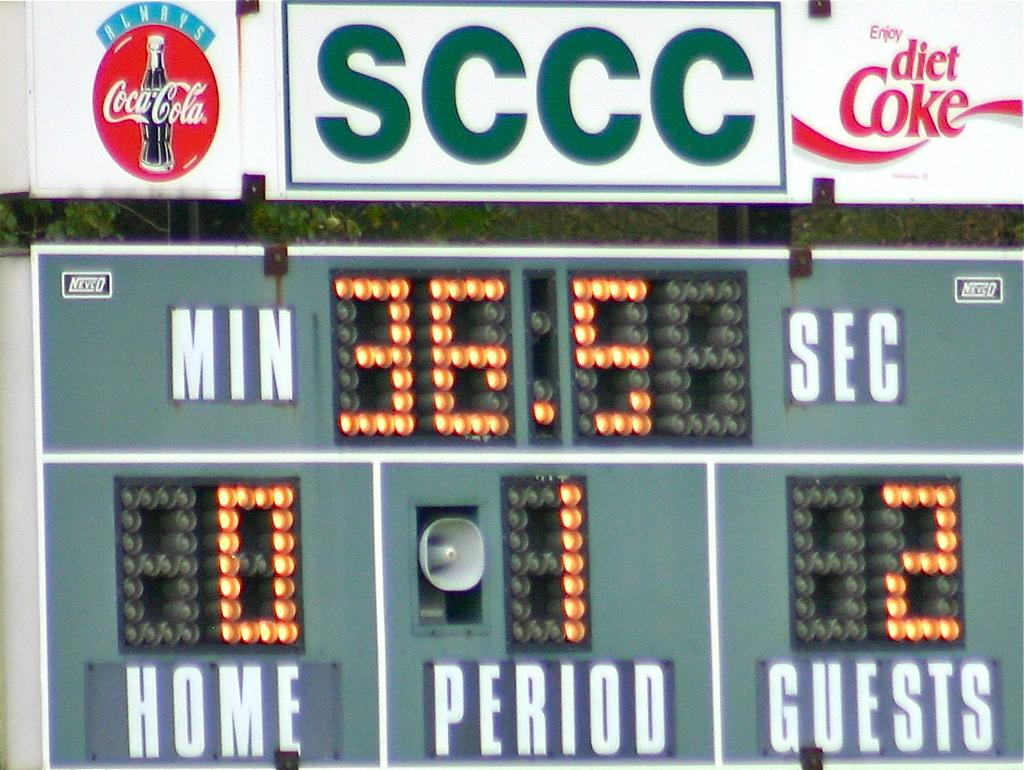Provide a one-sentence caption for the provided image. A scoreboard depicting the score of the guests having 2 points, and the home team having none. 